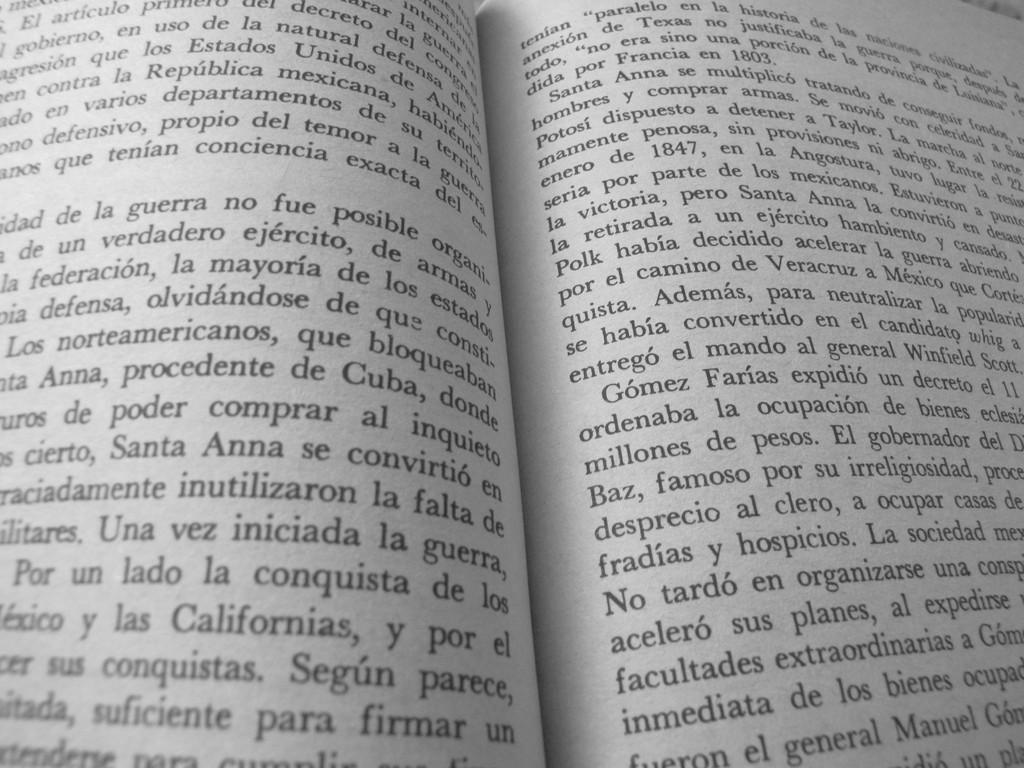<image>
Present a compact description of the photo's key features. Open page of a book which mentions the year 1847. 